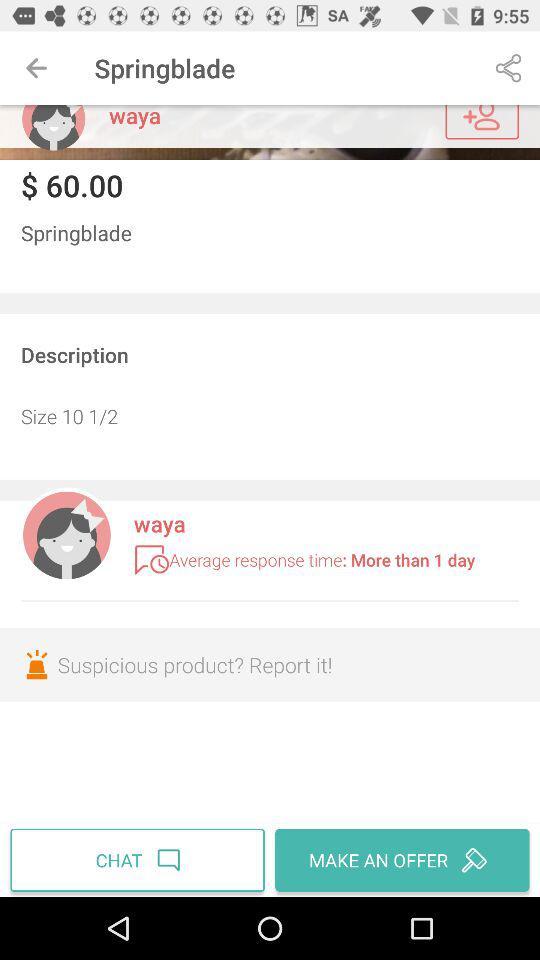What is the price of the Springblade? The price is $60.00. 